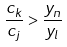Convert formula to latex. <formula><loc_0><loc_0><loc_500><loc_500>\frac { c _ { k } } { c _ { j } } > \frac { y _ { n } } { y _ { l } }</formula> 